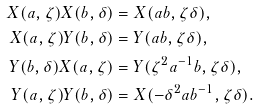<formula> <loc_0><loc_0><loc_500><loc_500>X ( a , \zeta ) X ( b , \delta ) & = X ( a b , \zeta \delta ) , \\ X ( a , \zeta ) Y ( b , \delta ) & = Y ( a b , \zeta \delta ) , \\ Y ( b , \delta ) X ( a , \zeta ) & = Y ( \zeta ^ { 2 } a ^ { - 1 } b , \zeta \delta ) , \\ Y ( a , \zeta ) Y ( b , \delta ) & = X ( - \delta ^ { 2 } a b ^ { - 1 } , \zeta \delta ) .</formula> 